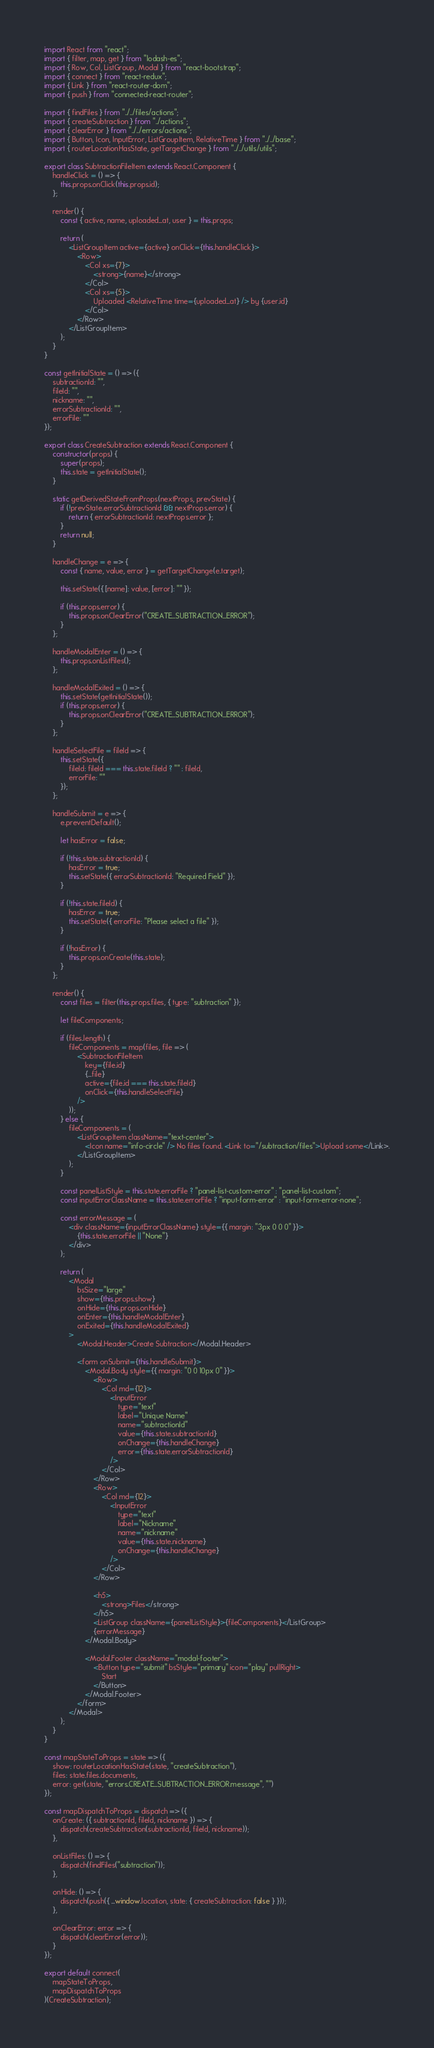Convert code to text. <code><loc_0><loc_0><loc_500><loc_500><_JavaScript_>import React from "react";
import { filter, map, get } from "lodash-es";
import { Row, Col, ListGroup, Modal } from "react-bootstrap";
import { connect } from "react-redux";
import { Link } from "react-router-dom";
import { push } from "connected-react-router";

import { findFiles } from "../../files/actions";
import { createSubtraction } from "../actions";
import { clearError } from "../../errors/actions";
import { Button, Icon, InputError, ListGroupItem, RelativeTime } from "../../base";
import { routerLocationHasState, getTargetChange } from "../../utils/utils";

export class SubtractionFileItem extends React.Component {
    handleClick = () => {
        this.props.onClick(this.props.id);
    };

    render() {
        const { active, name, uploaded_at, user } = this.props;

        return (
            <ListGroupItem active={active} onClick={this.handleClick}>
                <Row>
                    <Col xs={7}>
                        <strong>{name}</strong>
                    </Col>
                    <Col xs={5}>
                        Uploaded <RelativeTime time={uploaded_at} /> by {user.id}
                    </Col>
                </Row>
            </ListGroupItem>
        );
    }
}

const getInitialState = () => ({
    subtractionId: "",
    fileId: "",
    nickname: "",
    errorSubtractionId: "",
    errorFile: ""
});

export class CreateSubtraction extends React.Component {
    constructor(props) {
        super(props);
        this.state = getInitialState();
    }

    static getDerivedStateFromProps(nextProps, prevState) {
        if (!prevState.errorSubtractionId && nextProps.error) {
            return { errorSubtractionId: nextProps.error };
        }
        return null;
    }

    handleChange = e => {
        const { name, value, error } = getTargetChange(e.target);

        this.setState({ [name]: value, [error]: "" });

        if (this.props.error) {
            this.props.onClearError("CREATE_SUBTRACTION_ERROR");
        }
    };

    handleModalEnter = () => {
        this.props.onListFiles();
    };

    handleModalExited = () => {
        this.setState(getInitialState());
        if (this.props.error) {
            this.props.onClearError("CREATE_SUBTRACTION_ERROR");
        }
    };

    handleSelectFile = fileId => {
        this.setState({
            fileId: fileId === this.state.fileId ? "" : fileId,
            errorFile: ""
        });
    };

    handleSubmit = e => {
        e.preventDefault();

        let hasError = false;

        if (!this.state.subtractionId) {
            hasError = true;
            this.setState({ errorSubtractionId: "Required Field" });
        }

        if (!this.state.fileId) {
            hasError = true;
            this.setState({ errorFile: "Please select a file" });
        }

        if (!hasError) {
            this.props.onCreate(this.state);
        }
    };

    render() {
        const files = filter(this.props.files, { type: "subtraction" });

        let fileComponents;

        if (files.length) {
            fileComponents = map(files, file => (
                <SubtractionFileItem
                    key={file.id}
                    {...file}
                    active={file.id === this.state.fileId}
                    onClick={this.handleSelectFile}
                />
            ));
        } else {
            fileComponents = (
                <ListGroupItem className="text-center">
                    <Icon name="info-circle" /> No files found. <Link to="/subtraction/files">Upload some</Link>.
                </ListGroupItem>
            );
        }

        const panelListStyle = this.state.errorFile ? "panel-list-custom-error" : "panel-list-custom";
        const inputErrorClassName = this.state.errorFile ? "input-form-error" : "input-form-error-none";

        const errorMessage = (
            <div className={inputErrorClassName} style={{ margin: "3px 0 0 0" }}>
                {this.state.errorFile || "None"}
            </div>
        );

        return (
            <Modal
                bsSize="large"
                show={this.props.show}
                onHide={this.props.onHide}
                onEnter={this.handleModalEnter}
                onExited={this.handleModalExited}
            >
                <Modal.Header>Create Subtraction</Modal.Header>

                <form onSubmit={this.handleSubmit}>
                    <Modal.Body style={{ margin: "0 0 10px 0" }}>
                        <Row>
                            <Col md={12}>
                                <InputError
                                    type="text"
                                    label="Unique Name"
                                    name="subtractionId"
                                    value={this.state.subtractionId}
                                    onChange={this.handleChange}
                                    error={this.state.errorSubtractionId}
                                />
                            </Col>
                        </Row>
                        <Row>
                            <Col md={12}>
                                <InputError
                                    type="text"
                                    label="Nickname"
                                    name="nickname"
                                    value={this.state.nickname}
                                    onChange={this.handleChange}
                                />
                            </Col>
                        </Row>

                        <h5>
                            <strong>Files</strong>
                        </h5>
                        <ListGroup className={panelListStyle}>{fileComponents}</ListGroup>
                        {errorMessage}
                    </Modal.Body>

                    <Modal.Footer className="modal-footer">
                        <Button type="submit" bsStyle="primary" icon="play" pullRight>
                            Start
                        </Button>
                    </Modal.Footer>
                </form>
            </Modal>
        );
    }
}

const mapStateToProps = state => ({
    show: routerLocationHasState(state, "createSubtraction"),
    files: state.files.documents,
    error: get(state, "errors.CREATE_SUBTRACTION_ERROR.message", "")
});

const mapDispatchToProps = dispatch => ({
    onCreate: ({ subtractionId, fileId, nickname }) => {
        dispatch(createSubtraction(subtractionId, fileId, nickname));
    },

    onListFiles: () => {
        dispatch(findFiles("subtraction"));
    },

    onHide: () => {
        dispatch(push({ ...window.location, state: { createSubtraction: false } }));
    },

    onClearError: error => {
        dispatch(clearError(error));
    }
});

export default connect(
    mapStateToProps,
    mapDispatchToProps
)(CreateSubtraction);
</code> 